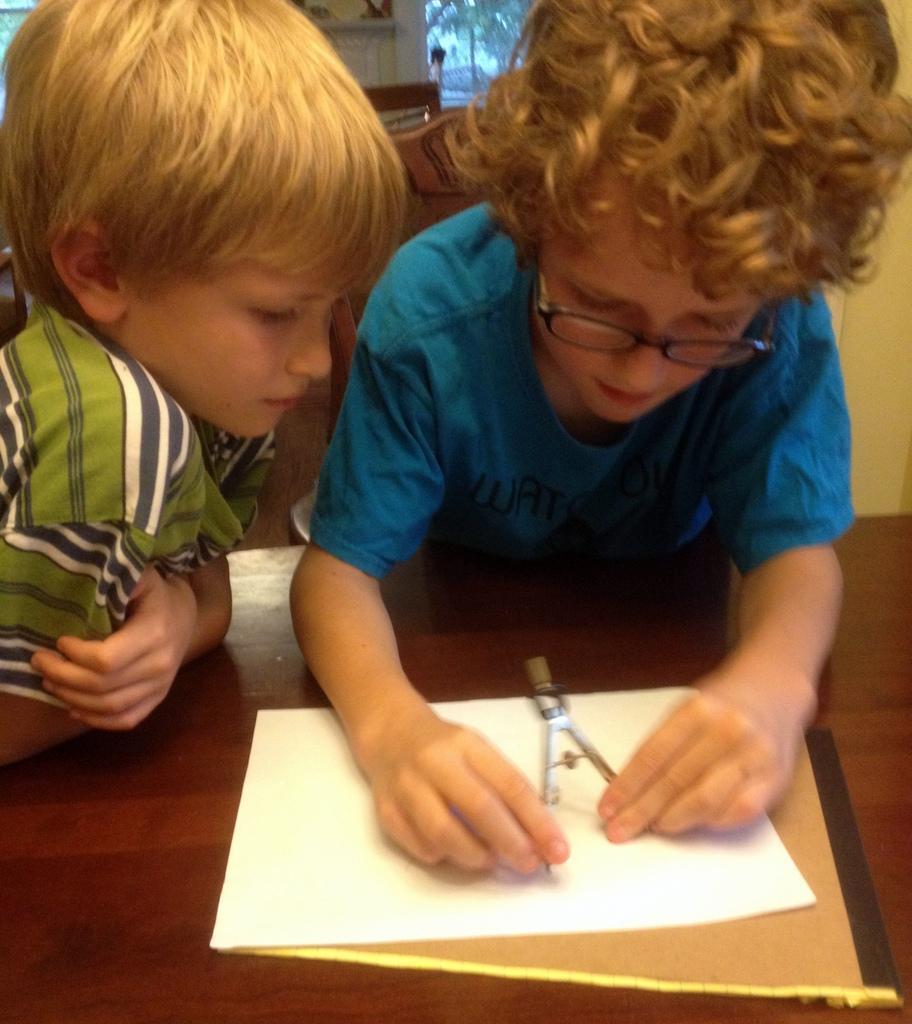How many children are present in the image? There are two kids in the image. What objects can be seen on the table in the image? There is a paper and a book on the table in the image. What color is the rose on the table in the image? There is no rose present in the image; only a paper and a book are visible on the table. 